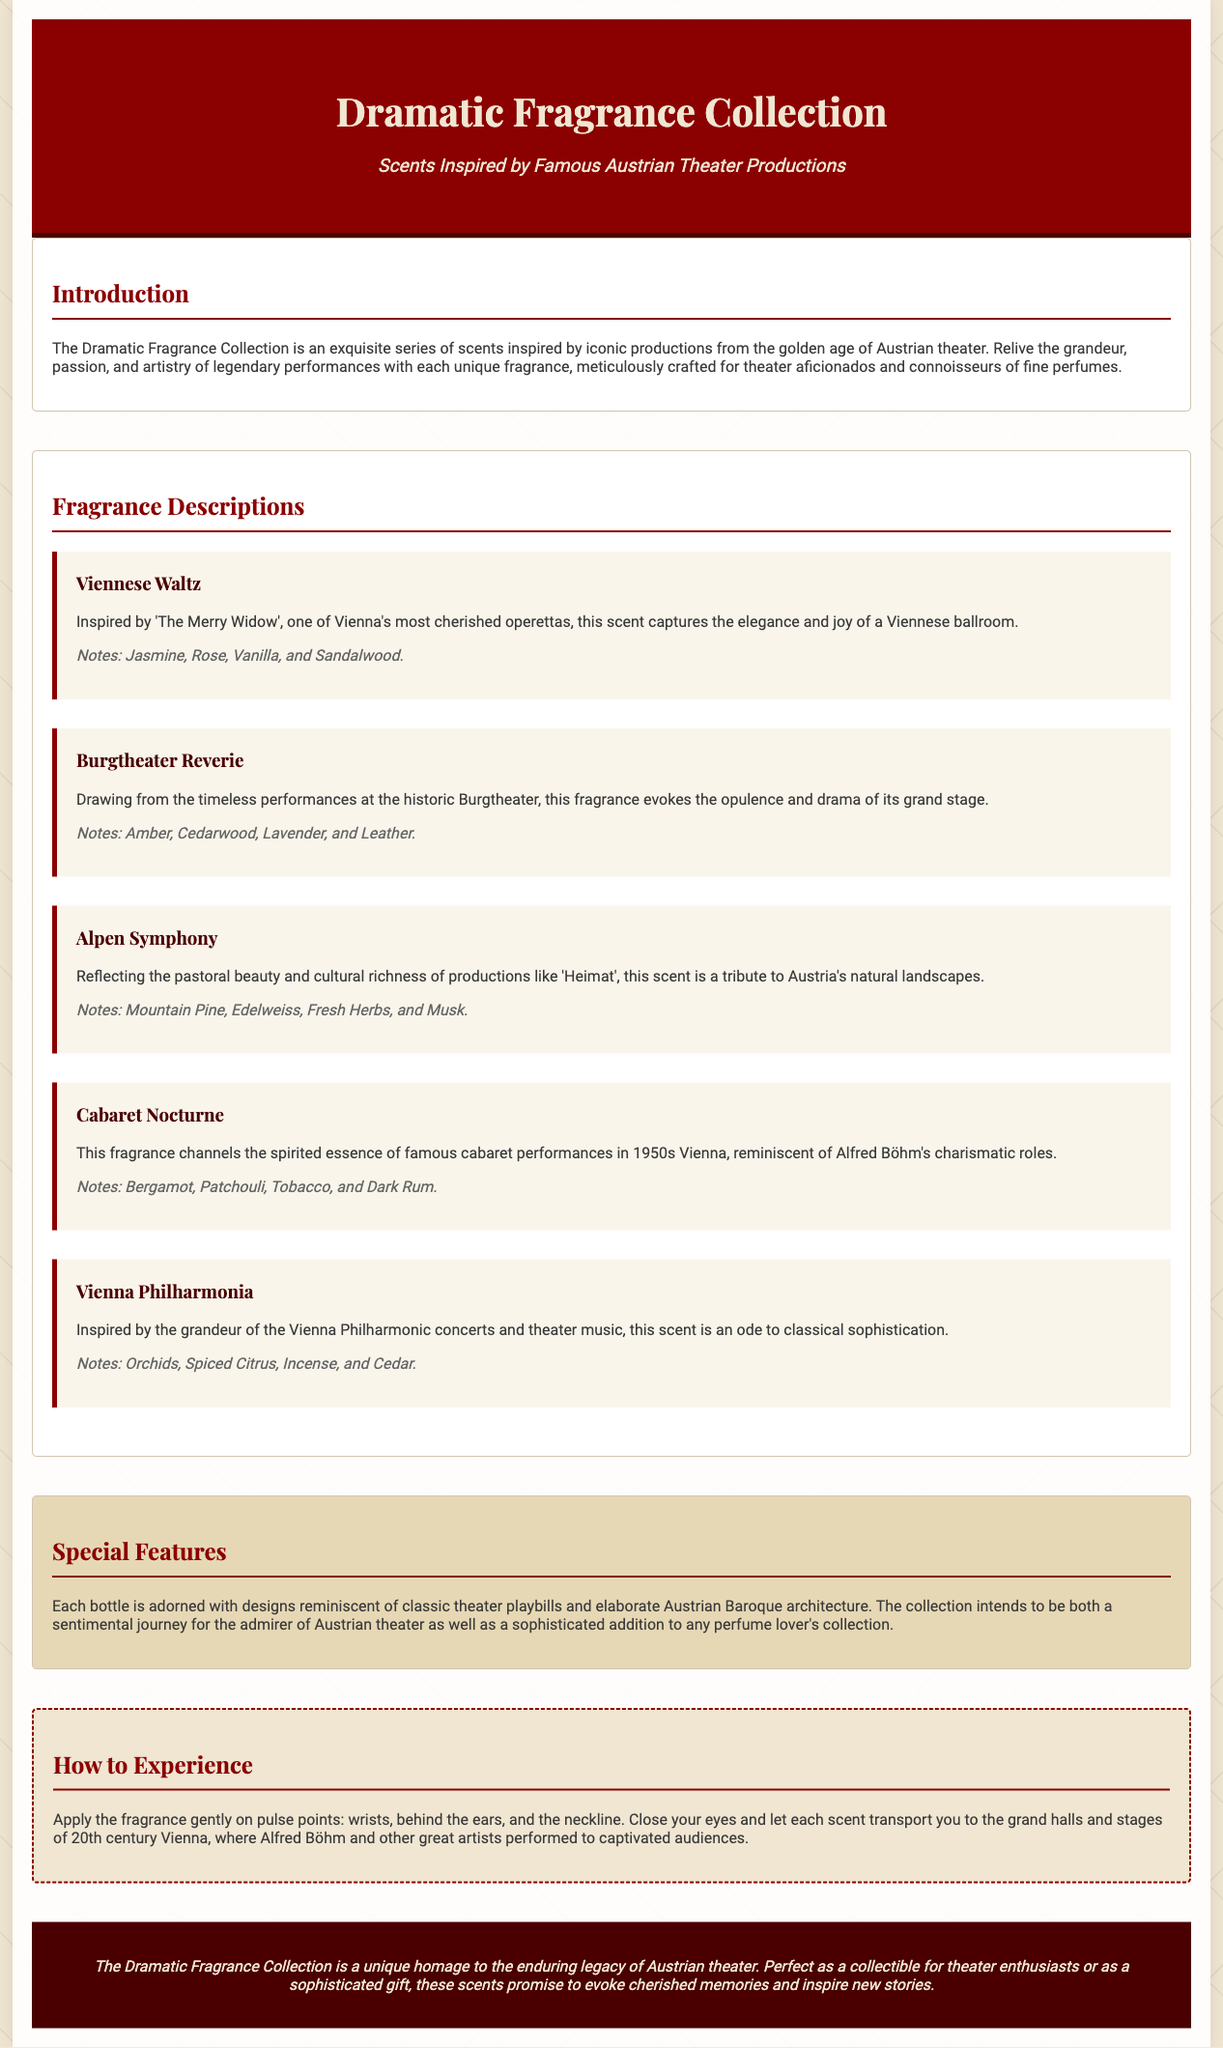What is the title of the collection? The title of the collection is mentioned in the header section of the document.
Answer: Dramatic Fragrance Collection Who is the collection inspired by? The subtitle indicates that the scents are inspired by famous Austrian theater productions.
Answer: Famous Austrian Theater Productions What fragrance is inspired by 'The Merry Widow'? The collection specifically describes which fragrance relates to the operetta in the scent descriptions.
Answer: Viennese Waltz What notes are in the scent 'Cabaret Nocturne'? The scent description provides the specific notes for this fragrance.
Answer: Bergamot, Patchouli, Tobacco, and Dark Rum How should the fragrance be applied? The section on How to Experience outlines the recommended application methods for the fragrances.
Answer: Pulse points: wrists, behind the ears, and the neckline What is a special feature of each bottle? The special features section highlights a particular characteristic of the bottles in the collection.
Answer: Designs reminiscent of classic theater playbills How many scents are described in the document? By counting the number of individual scent sections provided in the Fragrance Descriptions section.
Answer: Five 